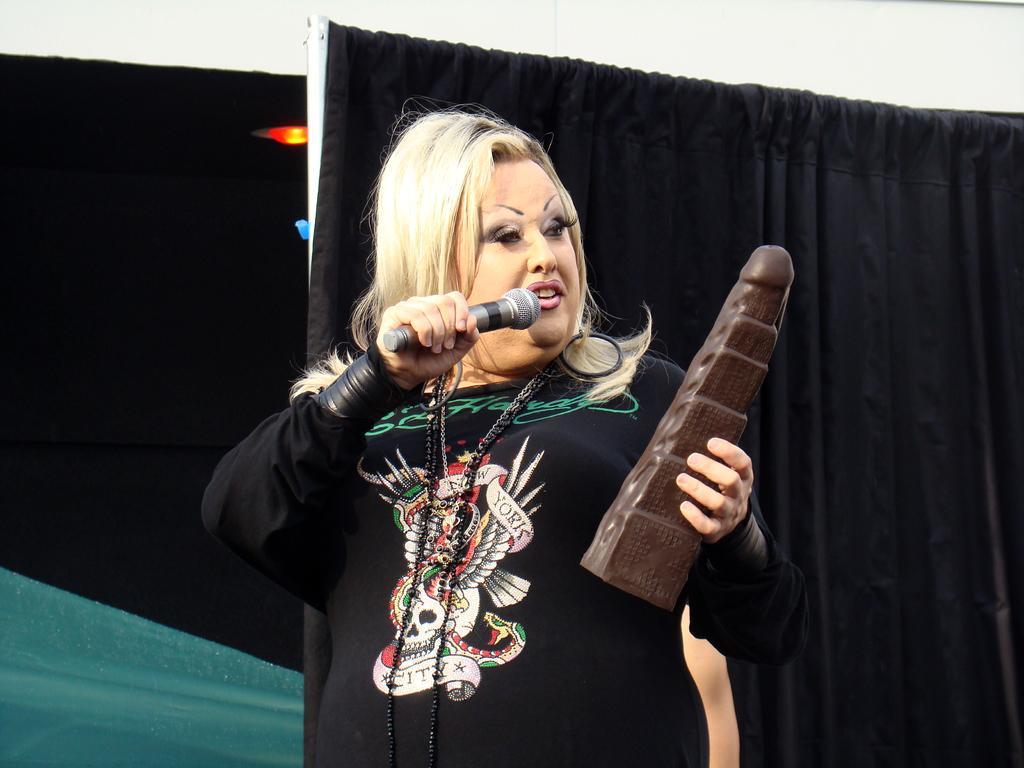In one or two sentences, can you explain what this image depicts? In the picture there is a woman in black dress holding a mic and another object. In the background there are black colored curtains. On the top it is a wall painted in white. 